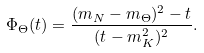<formula> <loc_0><loc_0><loc_500><loc_500>\Phi _ { \Theta } ( t ) = \frac { ( m _ { N } - m _ { \Theta } ) ^ { 2 } - t } { ( t - m _ { K } ^ { 2 } ) ^ { 2 } } .</formula> 